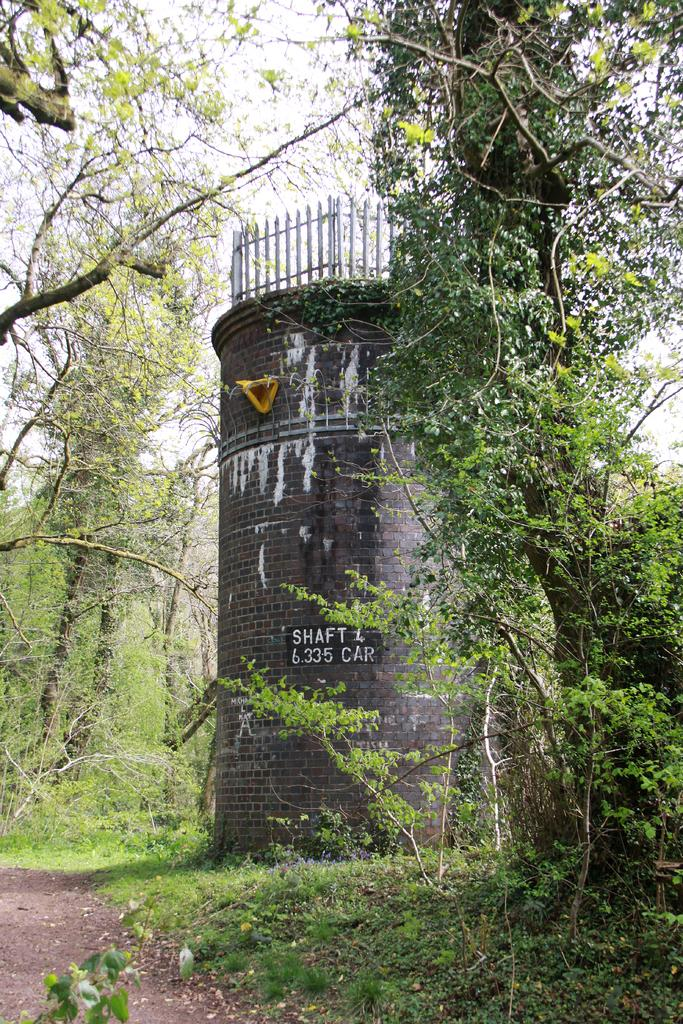What type of road is at the bottom of the image? There is a mud road at the bottom of the image. What can be seen in the corners of the image? There are trees in the left and right corners of the image. What structure is located in the foreground of the image? There is a building in the foreground of the image. What is visible at the top of the image? The sky is visible at the top of the image. What type of vegetable is being delivered in a parcel in the image? There is no parcel or vegetable present in the image. Are there any bears visible in the image? There are no bears present in the image. 